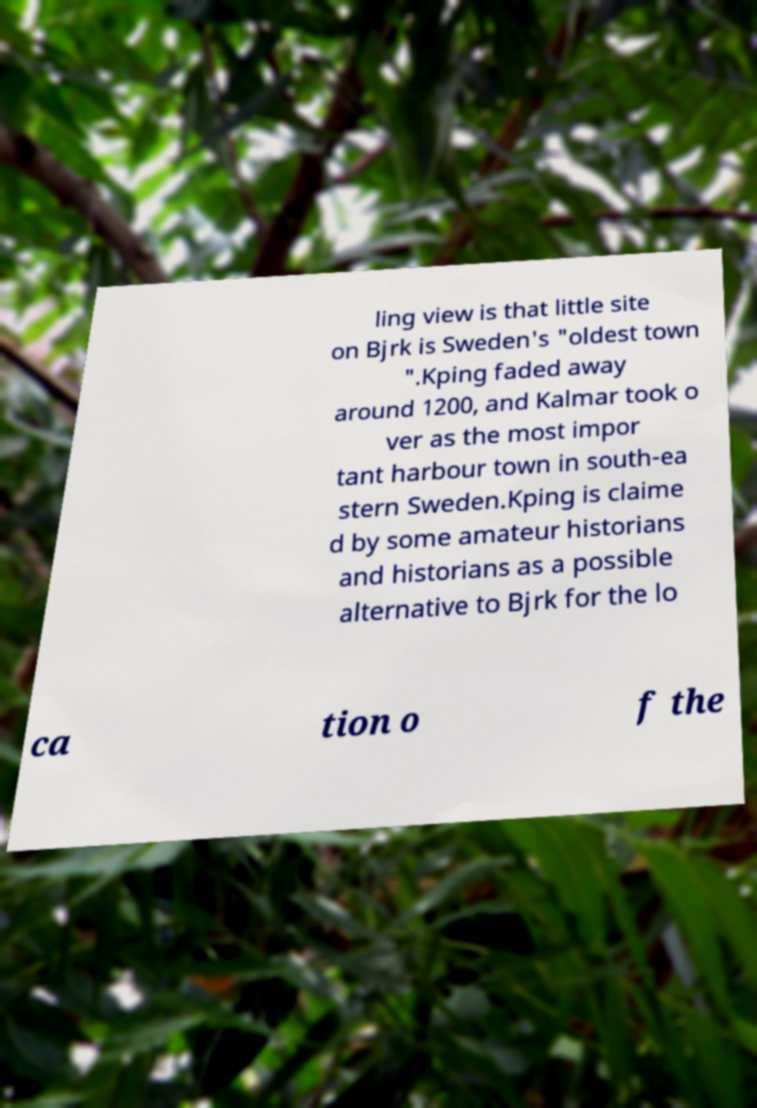Could you assist in decoding the text presented in this image and type it out clearly? ling view is that little site on Bjrk is Sweden's "oldest town ".Kping faded away around 1200, and Kalmar took o ver as the most impor tant harbour town in south-ea stern Sweden.Kping is claime d by some amateur historians and historians as a possible alternative to Bjrk for the lo ca tion o f the 